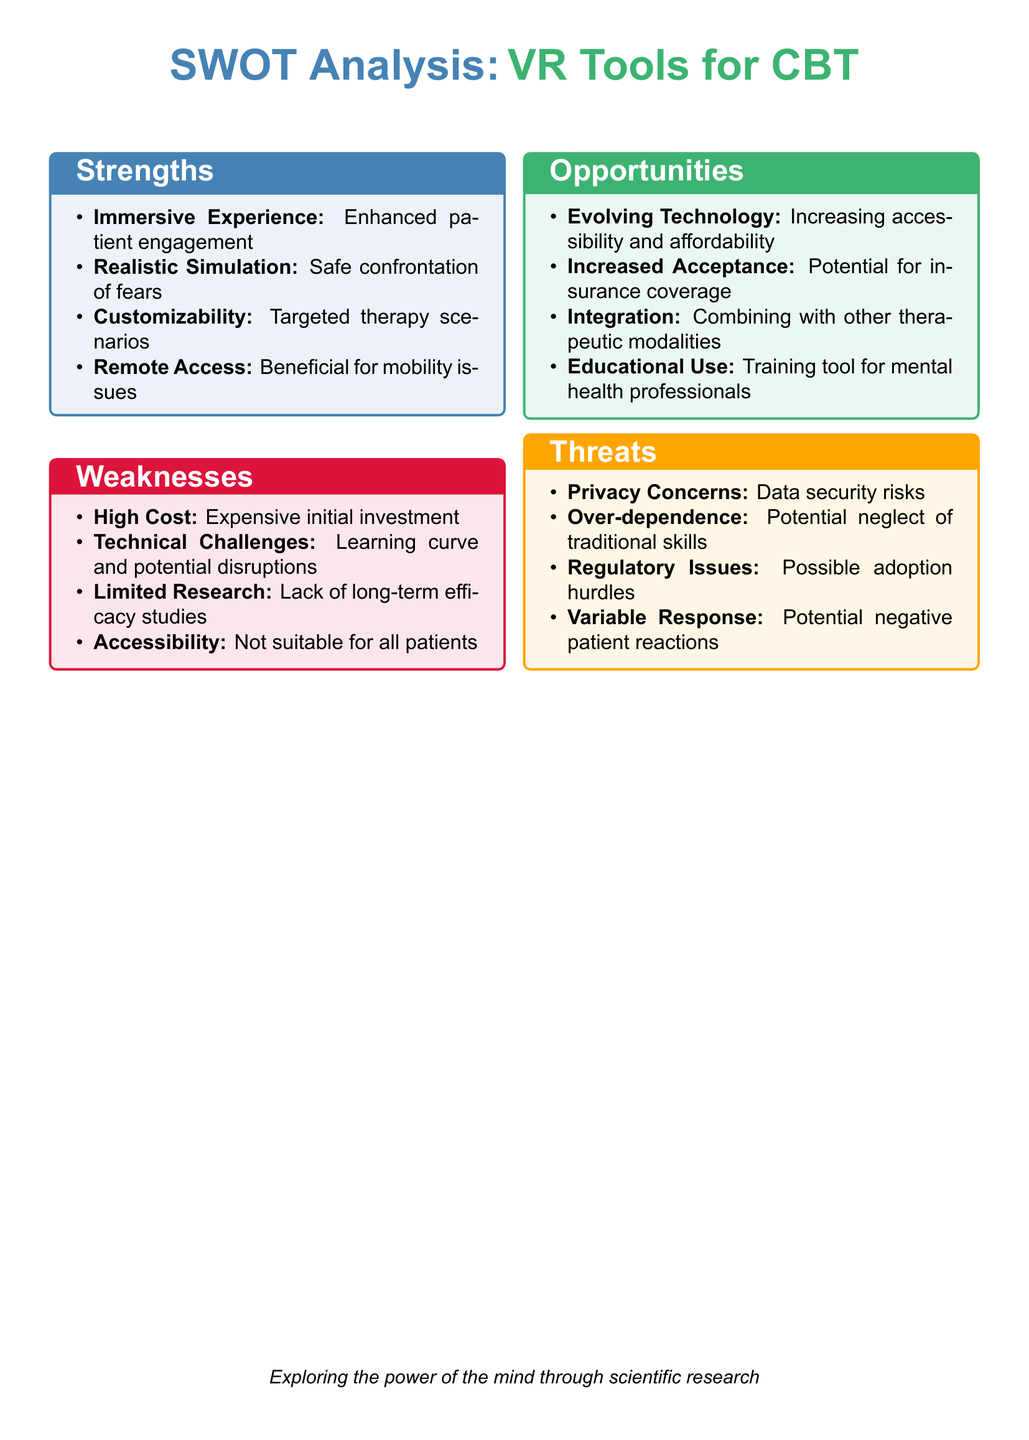What are two strengths of VR tools for CBT? The strengths listed are immersive experience, realistic simulation, customizability, and remote access.
Answer: Immersive experience; Realistic simulation What is one weakness related to the cost of VR tools for CBT? The document states that high cost is a concern as it involves expensive initial investment.
Answer: High Cost Name one opportunity presented in the document for VR tools in cognitive behavioral therapy. The opportunities include evolving technology, increased acceptance, integration, and educational use.
Answer: Evolving Technology What is one potential threat regarding patient reactions? The document mentions variable response as a threat, which indicates potential negative patient reactions.
Answer: Variable Response How many categories are presented in the SWOT analysis? The analysis includes four categories: strengths, weaknesses, opportunities, and threats.
Answer: Four What aspect of technology is evolving that may benefit VR tools for CBT? The document refers to increasing accessibility and affordability as a key aspect of evolving technology.
Answer: Increasing accessibility and affordability What is the benefit of VR tools mentioned for patients with mobility issues? The analysis discusses remote access as a benefit for patients with mobility issues.
Answer: Remote Access Is there a mention of educational use for VR tools in the document? Yes, educational use is noted as one of the opportunities in the analysis.
Answer: Yes 